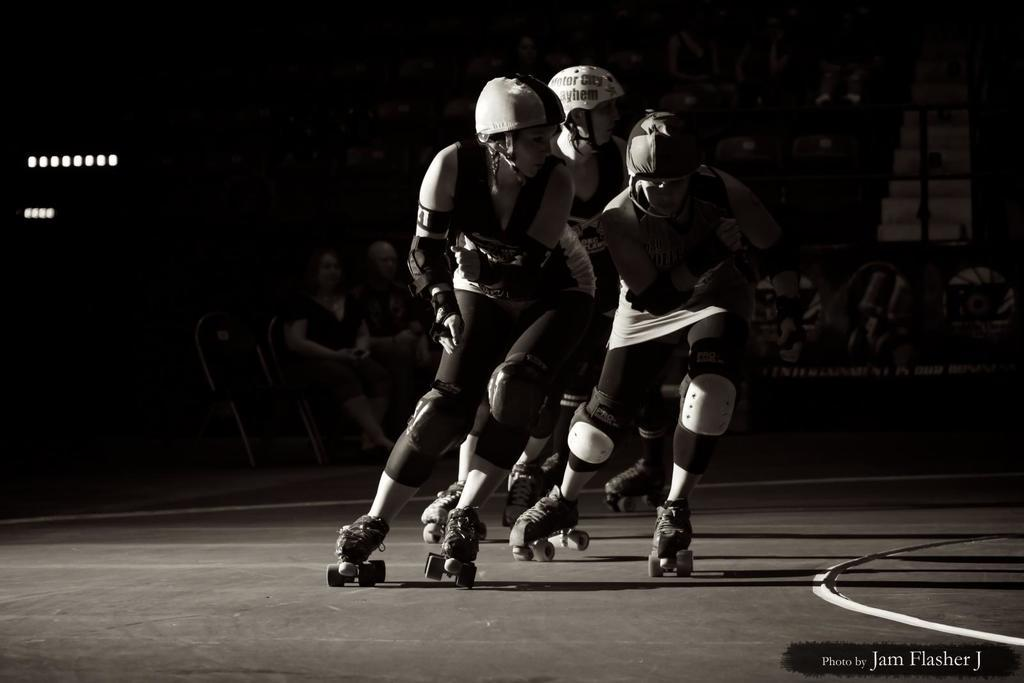What activity are the people in the image engaged in? The people in the image are skating. Where is the skating taking place in the image? The skating is taking place in the middle of the image. What are the people in the background of the image doing? The people in the background of the image are sitting and watching. What type of wood is being used to help the skaters in the image? There is no wood or assistance mentioned in the image; people are skating on their own. 